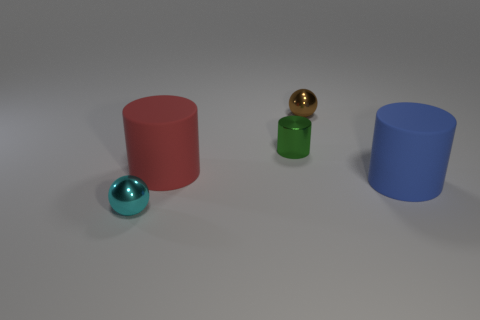Add 4 small blue metallic cylinders. How many objects exist? 9 Subtract all cylinders. How many objects are left? 2 Subtract 1 blue cylinders. How many objects are left? 4 Subtract all big blue cylinders. Subtract all small brown things. How many objects are left? 3 Add 5 brown spheres. How many brown spheres are left? 6 Add 4 big red things. How many big red things exist? 5 